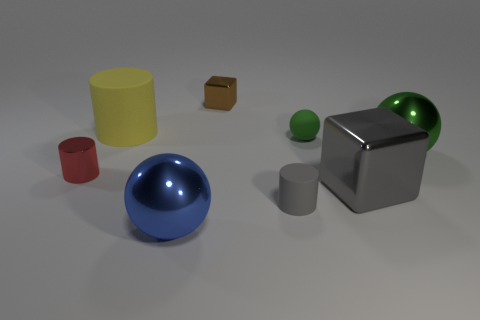What is the shape of the metallic object that is the same color as the tiny rubber ball?
Provide a short and direct response. Sphere. What number of other shiny objects are the same size as the green metallic thing?
Your answer should be compact. 2. There is a tiny matte object on the left side of the small green object; is there a small metal cube that is in front of it?
Your response must be concise. No. How many things are either brown cylinders or red metal things?
Make the answer very short. 1. What color is the block in front of the big sphere behind the shiny sphere that is in front of the big green shiny thing?
Your answer should be very brief. Gray. Is there anything else that is the same color as the large block?
Keep it short and to the point. Yes. Is the size of the gray metal object the same as the brown metal thing?
Your response must be concise. No. How many objects are either metal spheres that are in front of the red metallic cylinder or big shiny things that are behind the large metal block?
Give a very brief answer. 2. There is a green thing left of the shiny cube that is in front of the red cylinder; what is its material?
Make the answer very short. Rubber. How many other things are there of the same material as the small gray cylinder?
Offer a very short reply. 2. 